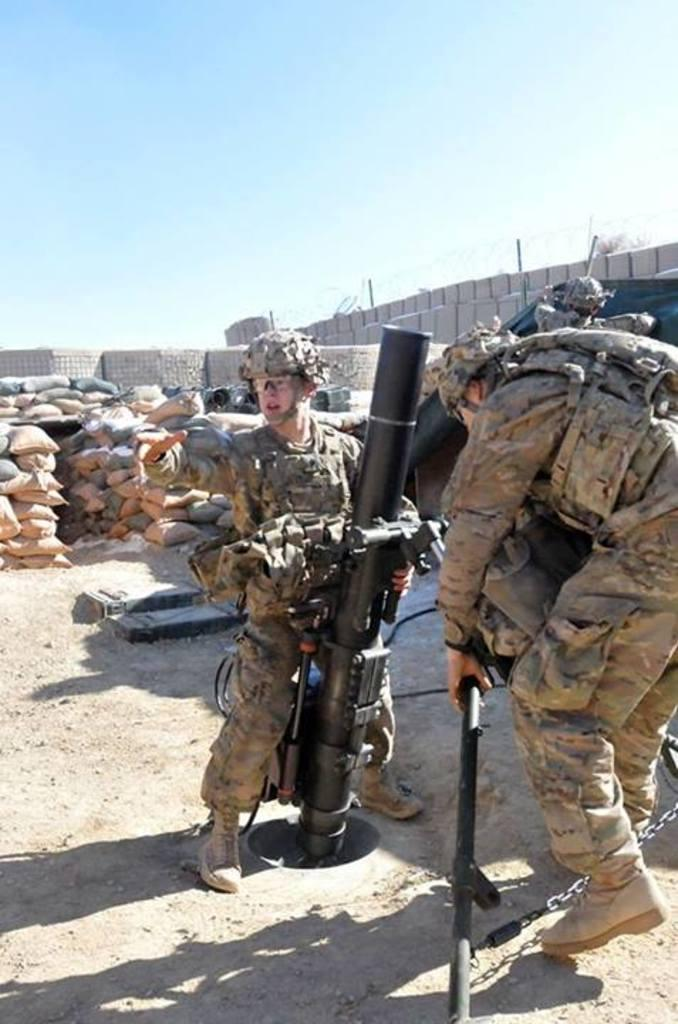What is the person in the foreground holding in the image? The person in the foreground is holding an object that resembles a missile. Where are the other people located in the image? The other people are on the right side of the image. What can be seen in the background of the image? There are sacks and other objects in the background, as well as the sky. How many girls are present in the image? There is no information about girls in the image, as the provided facts only mention a person holding an object that resembles a missile and other people on the right side of the image. 